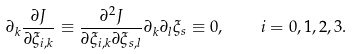<formula> <loc_0><loc_0><loc_500><loc_500>\partial _ { k } \frac { \partial J } { \partial \xi _ { i , k } } \equiv \frac { \partial ^ { 2 } J } { \partial \xi _ { i , k } \partial \xi _ { s , l } } \partial _ { k } \partial _ { l } \xi _ { s } \equiv 0 , \quad i = 0 , 1 , 2 , 3 .</formula> 